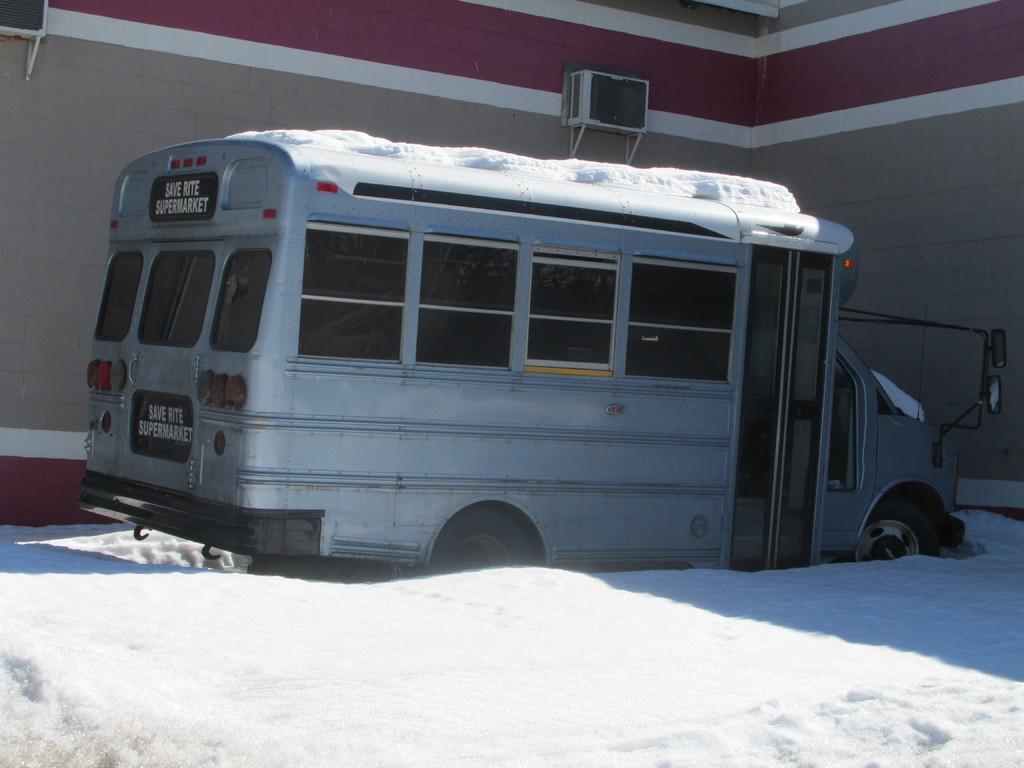Please provide a concise description of this image. In the center of image, we can see a vehicle on the snow and in the background, there is a building and we can see ac's to it. 